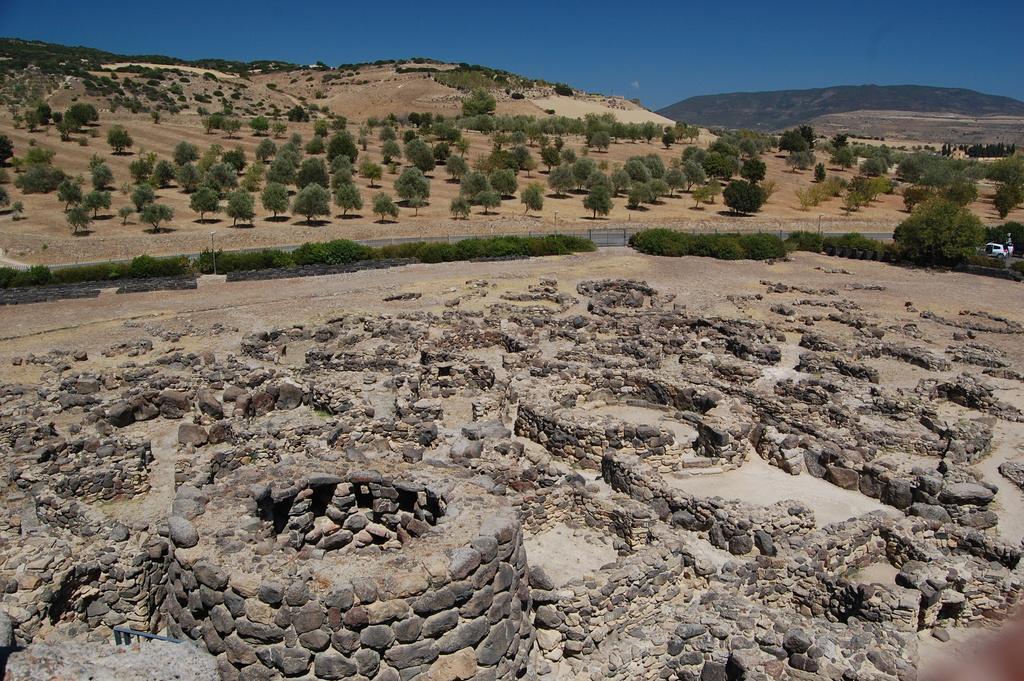Describe this image in one or two sentences. There is a land covered with a lot of rocks and sand,around that land there are plenty of trees and in the background there is a mountain. 